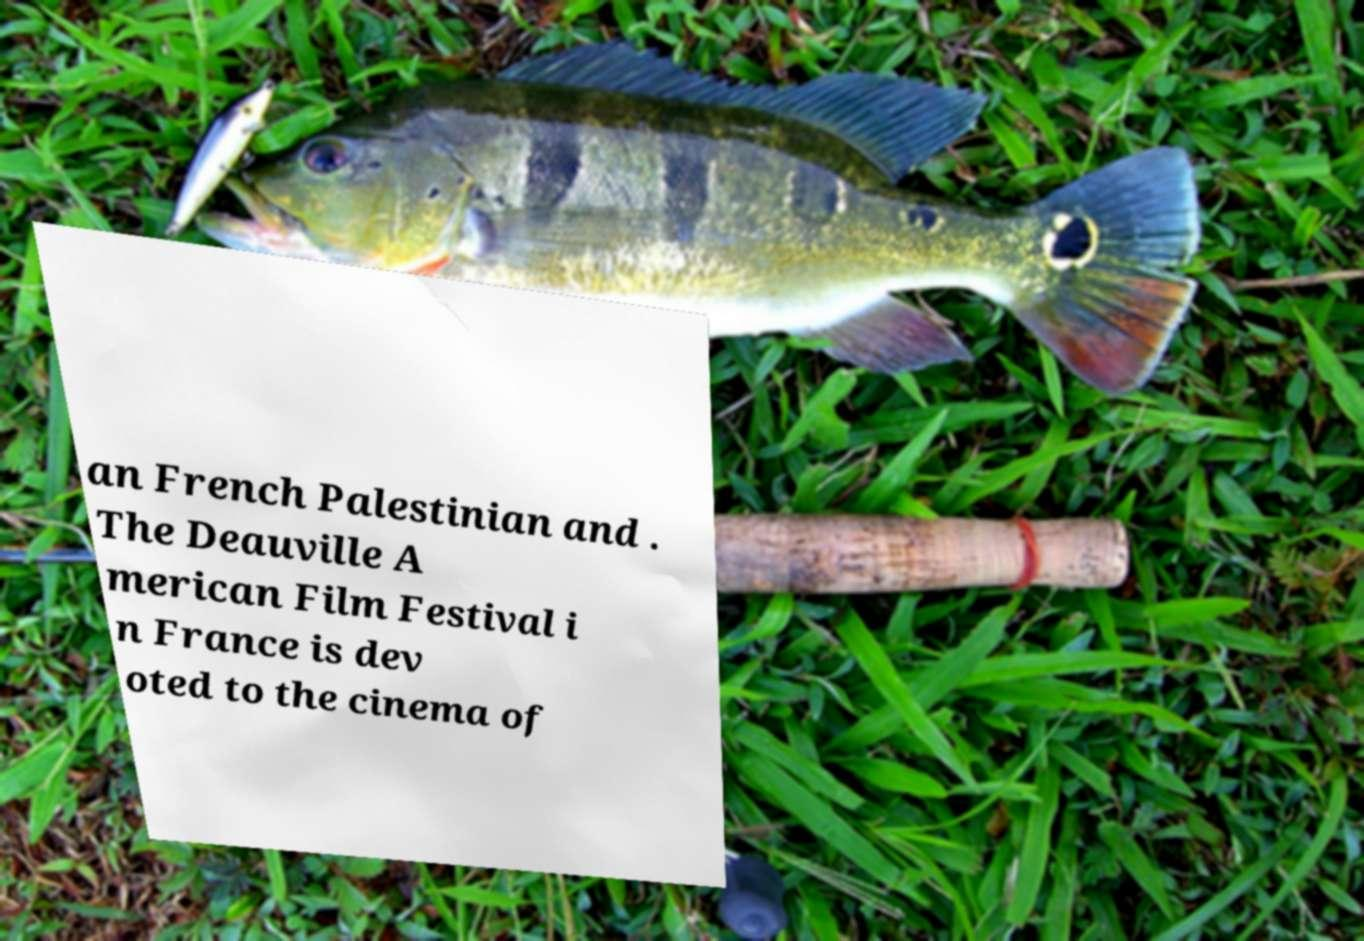Can you read and provide the text displayed in the image?This photo seems to have some interesting text. Can you extract and type it out for me? an French Palestinian and . The Deauville A merican Film Festival i n France is dev oted to the cinema of 